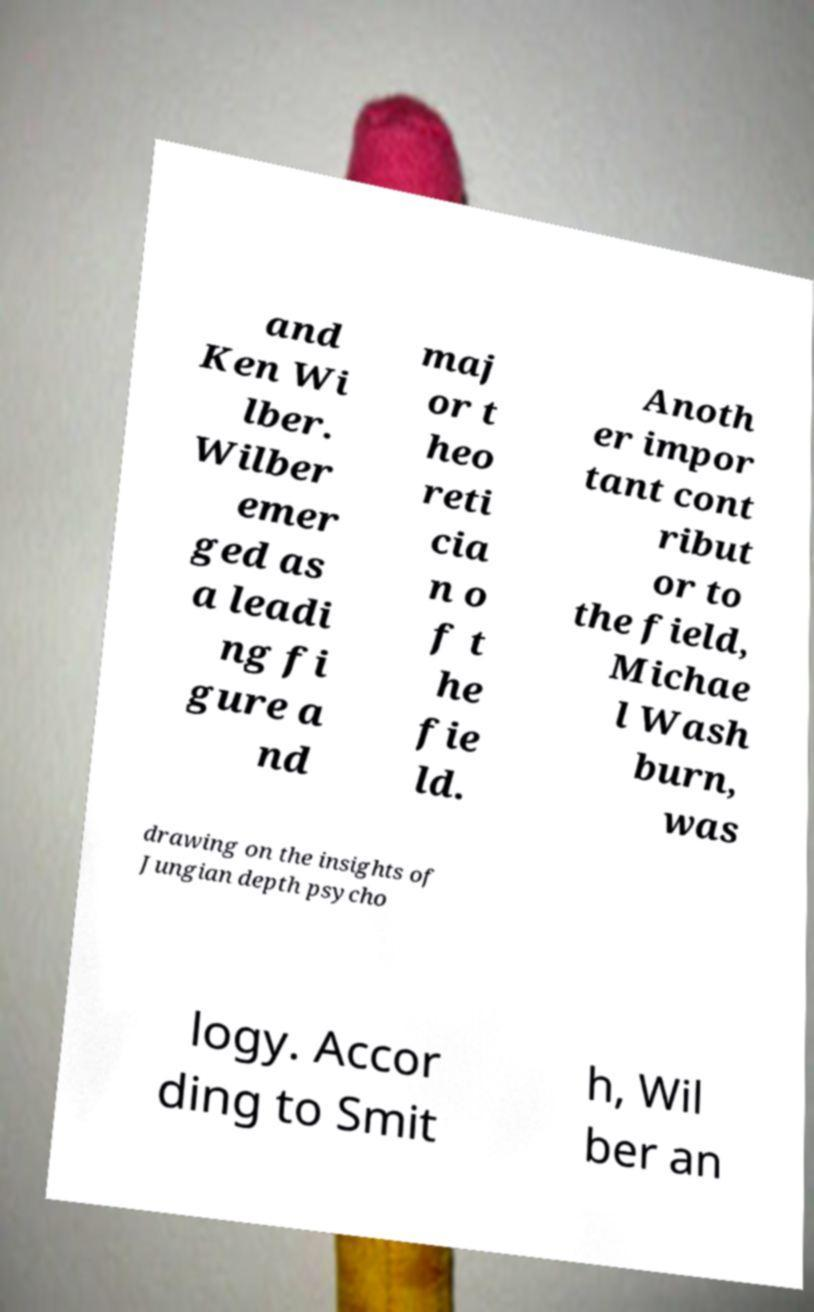Please read and relay the text visible in this image. What does it say? and Ken Wi lber. Wilber emer ged as a leadi ng fi gure a nd maj or t heo reti cia n o f t he fie ld. Anoth er impor tant cont ribut or to the field, Michae l Wash burn, was drawing on the insights of Jungian depth psycho logy. Accor ding to Smit h, Wil ber an 